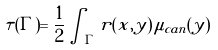Convert formula to latex. <formula><loc_0><loc_0><loc_500><loc_500>\tau ( \Gamma ) = \frac { 1 } { 2 } \int _ { \Gamma } r ( x , y ) \, \mu _ { c a n } ( y )</formula> 